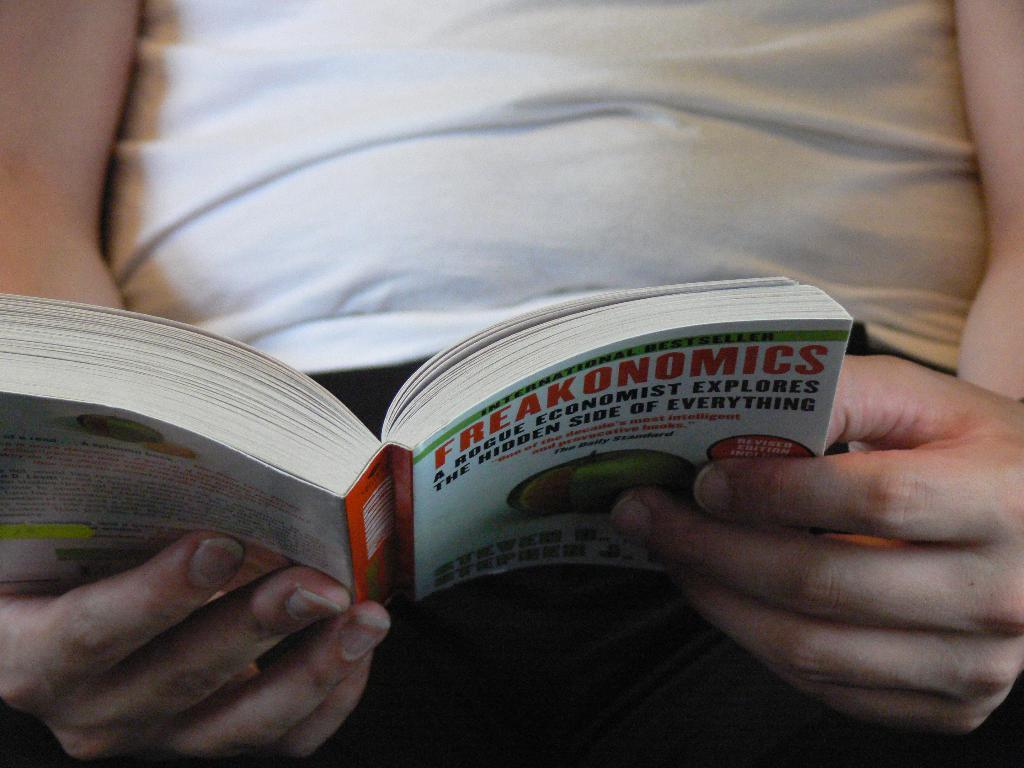<image>
Share a concise interpretation of the image provided. A white man holding a book titled Freakonomics. 